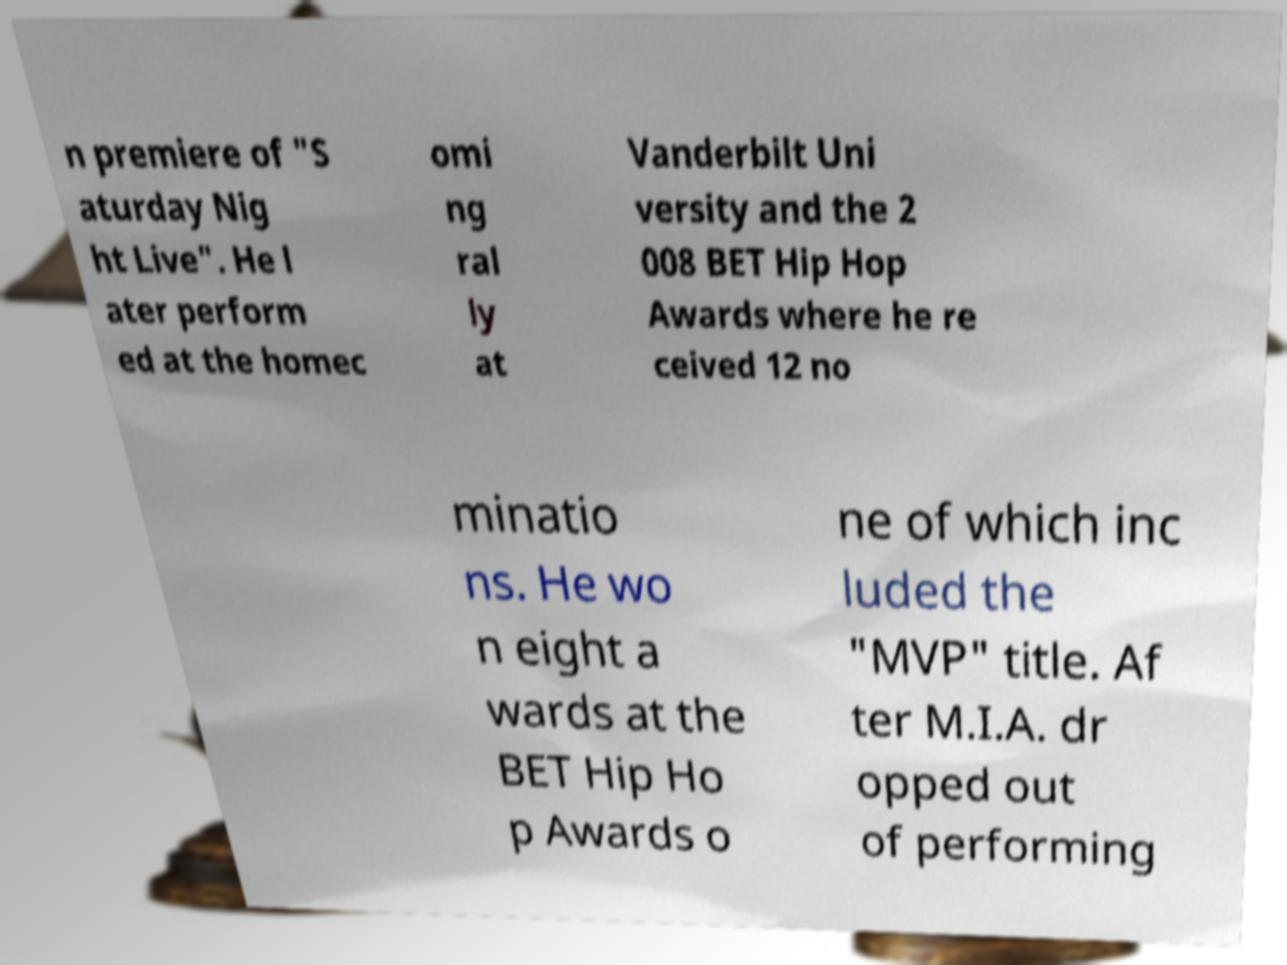Please identify and transcribe the text found in this image. n premiere of "S aturday Nig ht Live". He l ater perform ed at the homec omi ng ral ly at Vanderbilt Uni versity and the 2 008 BET Hip Hop Awards where he re ceived 12 no minatio ns. He wo n eight a wards at the BET Hip Ho p Awards o ne of which inc luded the "MVP" title. Af ter M.I.A. dr opped out of performing 